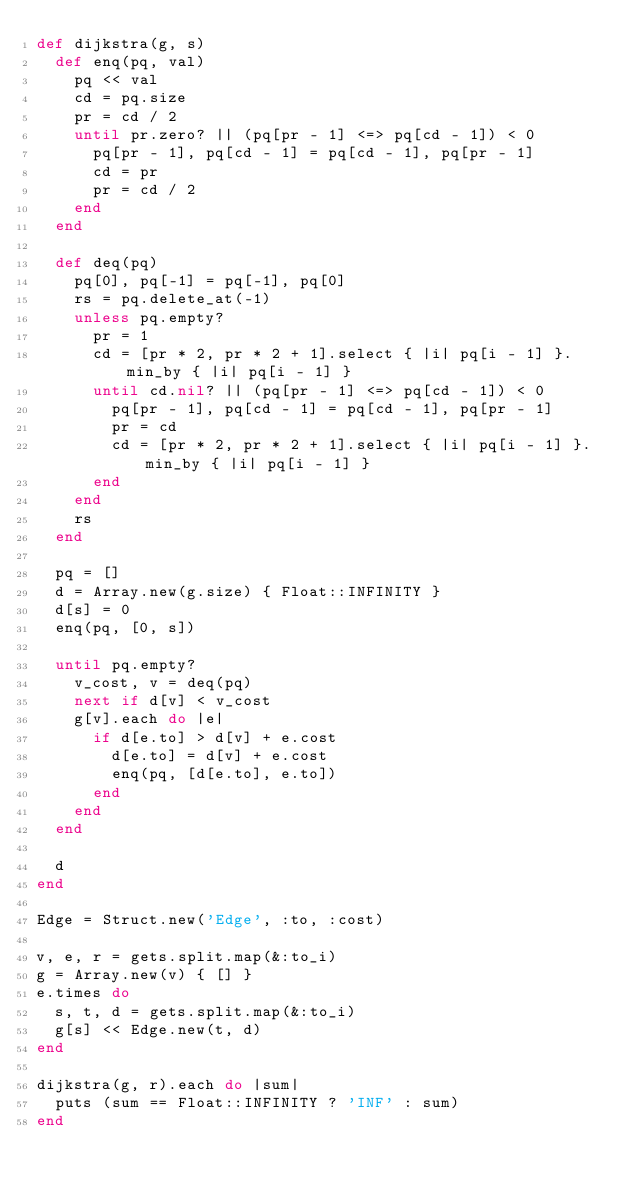<code> <loc_0><loc_0><loc_500><loc_500><_Ruby_>def dijkstra(g, s)
  def enq(pq, val)
    pq << val
    cd = pq.size
    pr = cd / 2
    until pr.zero? || (pq[pr - 1] <=> pq[cd - 1]) < 0
      pq[pr - 1], pq[cd - 1] = pq[cd - 1], pq[pr - 1]
      cd = pr
      pr = cd / 2
    end
  end

  def deq(pq)
    pq[0], pq[-1] = pq[-1], pq[0]
    rs = pq.delete_at(-1)
    unless pq.empty?
      pr = 1
      cd = [pr * 2, pr * 2 + 1].select { |i| pq[i - 1] }.min_by { |i| pq[i - 1] }
      until cd.nil? || (pq[pr - 1] <=> pq[cd - 1]) < 0
        pq[pr - 1], pq[cd - 1] = pq[cd - 1], pq[pr - 1]
        pr = cd
        cd = [pr * 2, pr * 2 + 1].select { |i| pq[i - 1] }.min_by { |i| pq[i - 1] }
      end
    end
    rs
  end

  pq = []
  d = Array.new(g.size) { Float::INFINITY }
  d[s] = 0
  enq(pq, [0, s])

  until pq.empty?
    v_cost, v = deq(pq)
    next if d[v] < v_cost
    g[v].each do |e|
      if d[e.to] > d[v] + e.cost
        d[e.to] = d[v] + e.cost
        enq(pq, [d[e.to], e.to])
      end
    end
  end

  d
end

Edge = Struct.new('Edge', :to, :cost)

v, e, r = gets.split.map(&:to_i)
g = Array.new(v) { [] }
e.times do
  s, t, d = gets.split.map(&:to_i)
  g[s] << Edge.new(t, d)
end

dijkstra(g, r).each do |sum|
  puts (sum == Float::INFINITY ? 'INF' : sum)
end</code> 